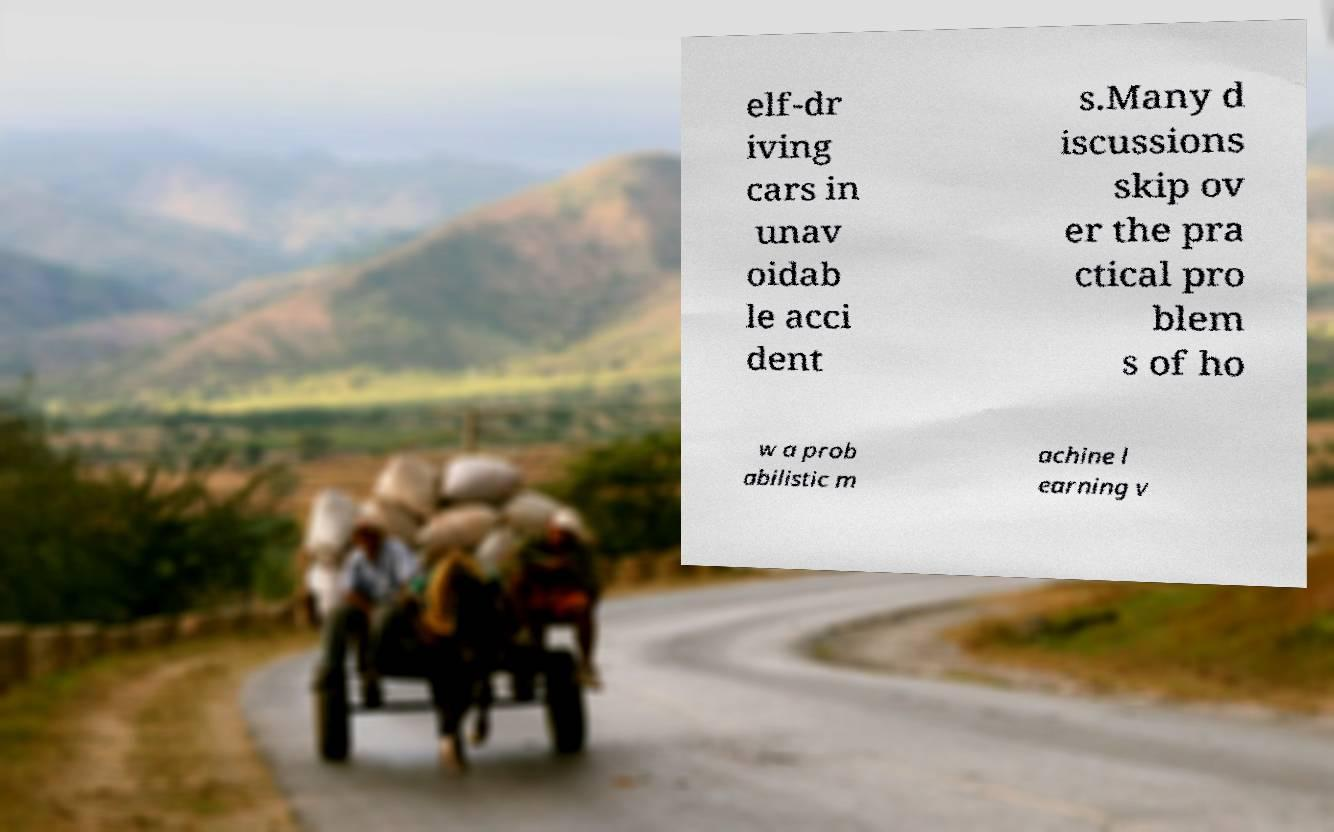Please read and relay the text visible in this image. What does it say? elf-dr iving cars in unav oidab le acci dent s.Many d iscussions skip ov er the pra ctical pro blem s of ho w a prob abilistic m achine l earning v 